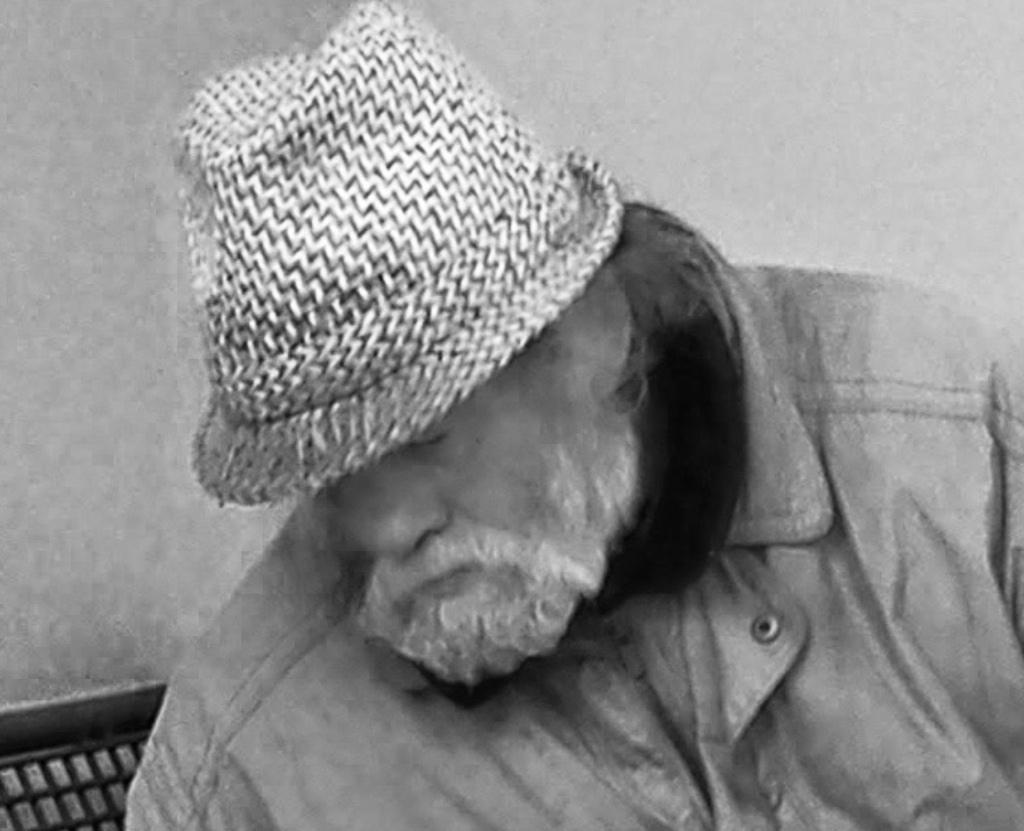Who or what is present in the image? There is a person in the image. What is the person wearing on their head? The person is wearing a cap. What can be seen in the background of the image? There is an object and a wall in the background of the image. What type of machine is being used by the person in the image? There is no machine present in the image; the person is simply wearing a cap. How does the person's throat appear in the image? The image does not show the person's throat, so it cannot be described. 